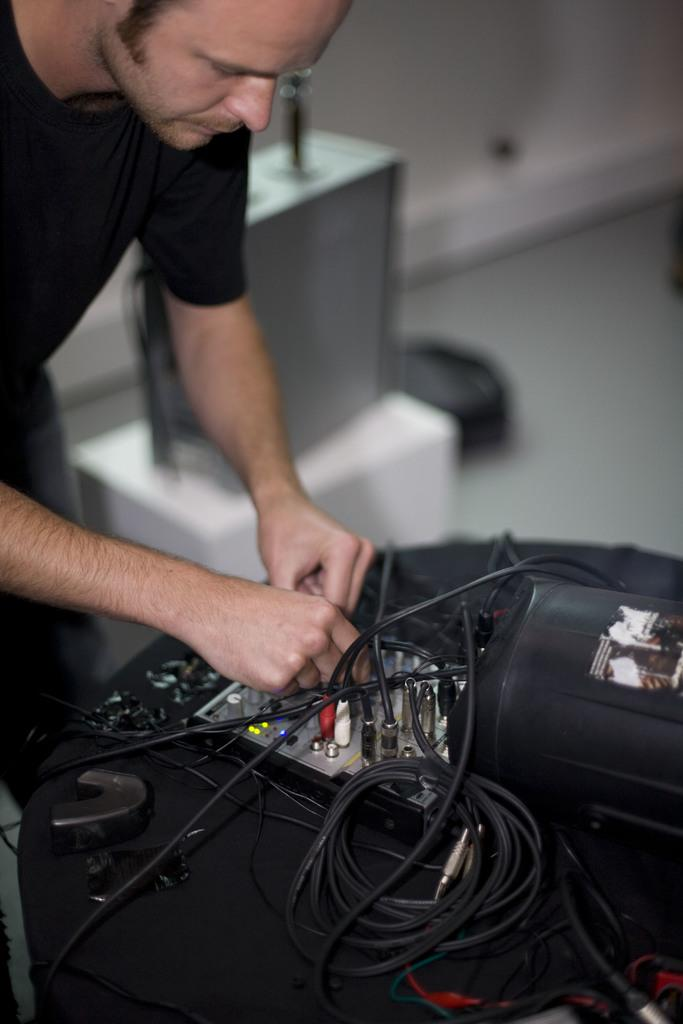Who is present in the image? There is a man in the image. What is the man wearing? The man is wearing a black t-shirt. What is the man doing in the image? The man is plugging a cable into a music instrument. What object can be seen near the man? There is a silver box visible in the image. What is the background of the image like? There is a white wall in the background of the image. What type of grain can be seen falling from the ceiling in the image? There is no grain falling from the ceiling in the image; it only features a man, a black t-shirt, a music instrument, a silver box, and a white wall. 